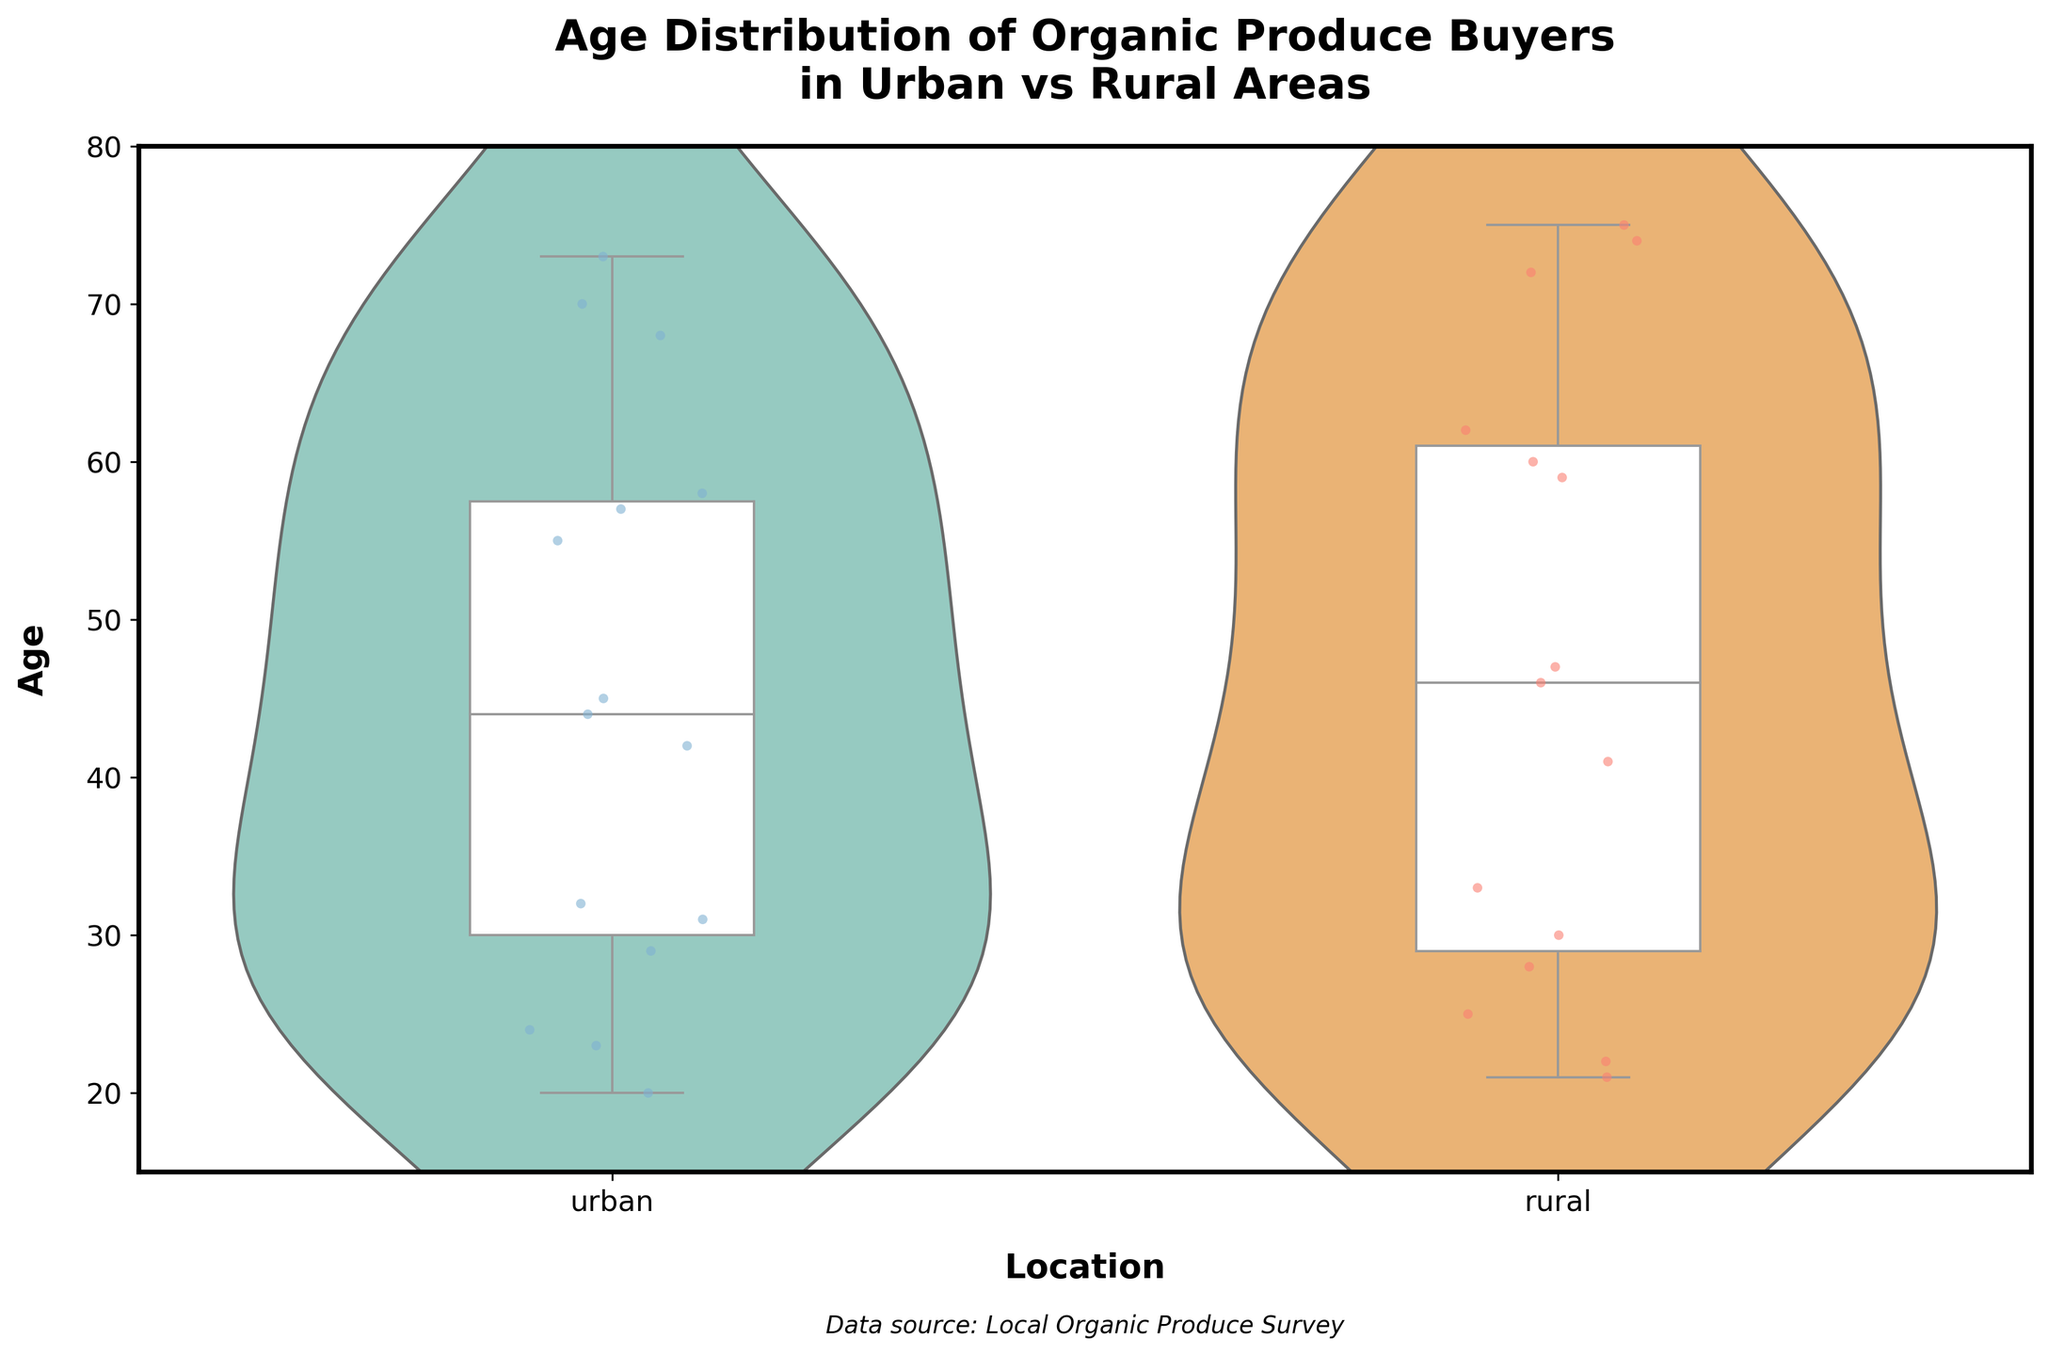What's the title of the chart? The title of the chart is located at the top and is written in bold. It helps understand the overall theme or topic of the visualization.
Answer: Age Distribution of Organic Produce Buyers in Urban vs Rural Areas Which location has the wider age distribution, urban or rural? By observing the violin plot width across the age groups, especially how spread out the colored violins are, we can infer which location has a wider age distribution. Wider violin indicates more variability.
Answer: Rural What is the median age of organic produce buyers in urban areas? The box plot overlay in the violin chart gives the median line. The white line in the urban section at approximately age 44 marks the median.
Answer: 44 Are there any visible outliers in the age data for either location? Outliers would typically be shown as individual points outside the whiskers of the box plot. Since we are instructed that outliers are not shown, we note that no explicit outliers can be observed.
Answer: No Which location appears to have more younger buyers aged between 18-25? By comparing the densities of the violin plots in the 18-25 age range, we can see which location has a thicker section, indicating more buyers. Urban has a slightly thicker section in this range.
Answer: Urban What is the range of ages for organic produce buyers in rural areas? The range can be determined by the top and bottom points of the box plot's whiskers. In the rural section, the whiskers extend from approximately 21 to 75.
Answer: 21 to 75 Which location has a higher median age for its buyers? Comparing the medians, which is indicated by the white line in each box plot, the rural median is higher than the urban median.
Answer: Rural What ages appear to be the most common for buyers in urban areas? The density of the violin plot indicates the most common values. In urban areas, the density is highest around 43-45 years old, showing that these ages are most common.
Answer: 43-45 years old Is there a significant overlap in age distribution between the two locations? By examining how much the violin plots overlap, especially in the middle age ranges, we can determine if there's significant overlap. The plots do overlap significantly between the ages of roughly 30 to 60.
Answer: Yes, between 30 to 60 In which location do the ages of buyers appear more evenly distributed across the range? The uniformity in spread of the violin plot indicates even distribution. The rural density seems more uniform across different ages compared to the urban area.
Answer: Rural 